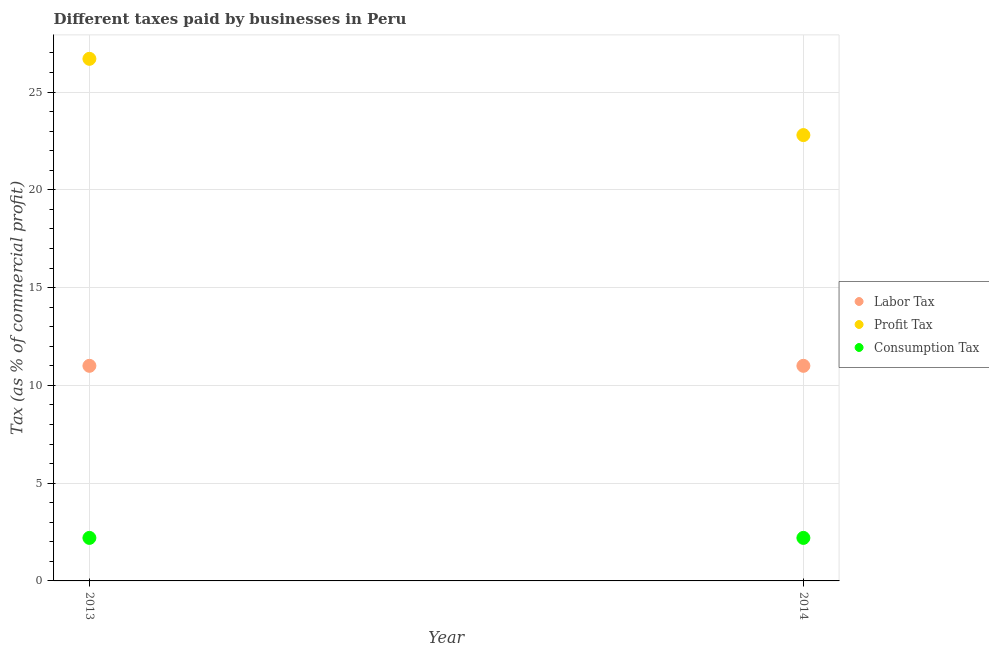What is the percentage of labor tax in 2014?
Make the answer very short. 11. Across all years, what is the maximum percentage of labor tax?
Provide a succinct answer. 11. Across all years, what is the minimum percentage of labor tax?
Provide a succinct answer. 11. In which year was the percentage of labor tax minimum?
Keep it short and to the point. 2013. What is the total percentage of profit tax in the graph?
Your answer should be compact. 49.5. What is the difference between the percentage of labor tax in 2013 and that in 2014?
Ensure brevity in your answer.  0. What is the difference between the percentage of labor tax in 2014 and the percentage of profit tax in 2013?
Provide a short and direct response. -15.7. In the year 2013, what is the difference between the percentage of labor tax and percentage of profit tax?
Make the answer very short. -15.7. What is the ratio of the percentage of profit tax in 2013 to that in 2014?
Ensure brevity in your answer.  1.17. Is the percentage of consumption tax strictly greater than the percentage of profit tax over the years?
Ensure brevity in your answer.  No. How many years are there in the graph?
Make the answer very short. 2. Are the values on the major ticks of Y-axis written in scientific E-notation?
Give a very brief answer. No. How many legend labels are there?
Keep it short and to the point. 3. How are the legend labels stacked?
Provide a short and direct response. Vertical. What is the title of the graph?
Your response must be concise. Different taxes paid by businesses in Peru. What is the label or title of the Y-axis?
Your response must be concise. Tax (as % of commercial profit). What is the Tax (as % of commercial profit) of Profit Tax in 2013?
Your answer should be compact. 26.7. What is the Tax (as % of commercial profit) in Consumption Tax in 2013?
Make the answer very short. 2.2. What is the Tax (as % of commercial profit) of Profit Tax in 2014?
Ensure brevity in your answer.  22.8. What is the Tax (as % of commercial profit) of Consumption Tax in 2014?
Offer a terse response. 2.2. Across all years, what is the maximum Tax (as % of commercial profit) in Profit Tax?
Keep it short and to the point. 26.7. Across all years, what is the maximum Tax (as % of commercial profit) of Consumption Tax?
Provide a short and direct response. 2.2. Across all years, what is the minimum Tax (as % of commercial profit) of Profit Tax?
Offer a terse response. 22.8. Across all years, what is the minimum Tax (as % of commercial profit) in Consumption Tax?
Keep it short and to the point. 2.2. What is the total Tax (as % of commercial profit) in Labor Tax in the graph?
Your answer should be compact. 22. What is the total Tax (as % of commercial profit) in Profit Tax in the graph?
Offer a terse response. 49.5. What is the total Tax (as % of commercial profit) in Consumption Tax in the graph?
Your answer should be compact. 4.4. What is the difference between the Tax (as % of commercial profit) of Labor Tax in 2013 and that in 2014?
Give a very brief answer. 0. What is the difference between the Tax (as % of commercial profit) in Profit Tax in 2013 and that in 2014?
Your response must be concise. 3.9. What is the difference between the Tax (as % of commercial profit) in Consumption Tax in 2013 and that in 2014?
Offer a very short reply. 0. What is the difference between the Tax (as % of commercial profit) of Labor Tax in 2013 and the Tax (as % of commercial profit) of Consumption Tax in 2014?
Make the answer very short. 8.8. What is the difference between the Tax (as % of commercial profit) of Profit Tax in 2013 and the Tax (as % of commercial profit) of Consumption Tax in 2014?
Your answer should be compact. 24.5. What is the average Tax (as % of commercial profit) in Labor Tax per year?
Offer a very short reply. 11. What is the average Tax (as % of commercial profit) in Profit Tax per year?
Give a very brief answer. 24.75. In the year 2013, what is the difference between the Tax (as % of commercial profit) in Labor Tax and Tax (as % of commercial profit) in Profit Tax?
Offer a terse response. -15.7. In the year 2013, what is the difference between the Tax (as % of commercial profit) of Labor Tax and Tax (as % of commercial profit) of Consumption Tax?
Offer a very short reply. 8.8. In the year 2013, what is the difference between the Tax (as % of commercial profit) in Profit Tax and Tax (as % of commercial profit) in Consumption Tax?
Offer a very short reply. 24.5. In the year 2014, what is the difference between the Tax (as % of commercial profit) in Profit Tax and Tax (as % of commercial profit) in Consumption Tax?
Offer a very short reply. 20.6. What is the ratio of the Tax (as % of commercial profit) of Profit Tax in 2013 to that in 2014?
Your response must be concise. 1.17. What is the difference between the highest and the second highest Tax (as % of commercial profit) in Labor Tax?
Give a very brief answer. 0. What is the difference between the highest and the second highest Tax (as % of commercial profit) in Consumption Tax?
Offer a terse response. 0. What is the difference between the highest and the lowest Tax (as % of commercial profit) of Labor Tax?
Make the answer very short. 0. 